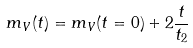Convert formula to latex. <formula><loc_0><loc_0><loc_500><loc_500>m _ { V } ( t ) = m _ { V } ( t = 0 ) + 2 \frac { t } { t _ { 2 } }</formula> 